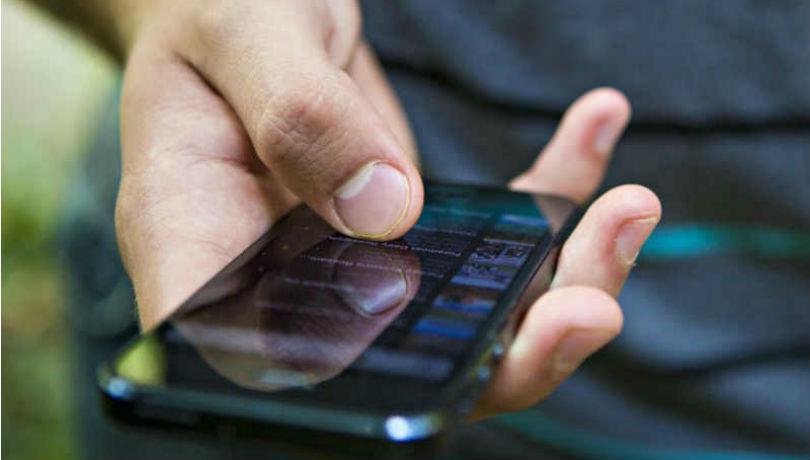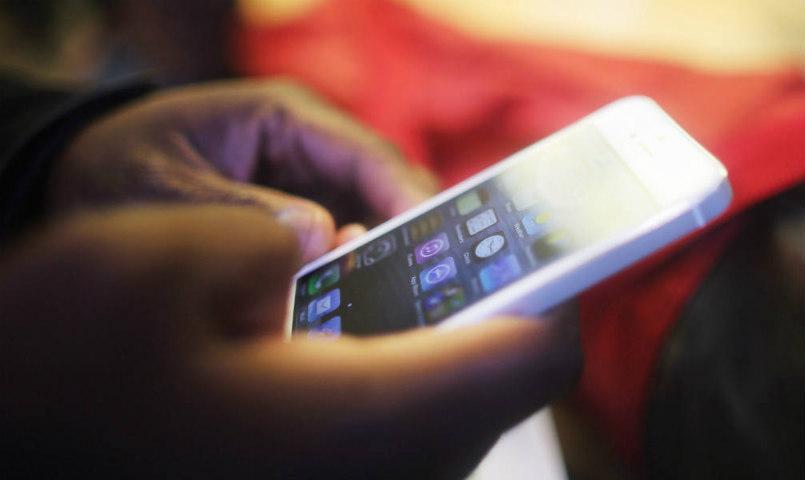The first image is the image on the left, the second image is the image on the right. For the images displayed, is the sentence "The phone in the left image is black and the phone in the right image is white." factually correct? Answer yes or no. Yes. The first image is the image on the left, the second image is the image on the right. Examine the images to the left and right. Is the description "In one of the images, a person is typing on a phone with physical keys." accurate? Answer yes or no. No. 